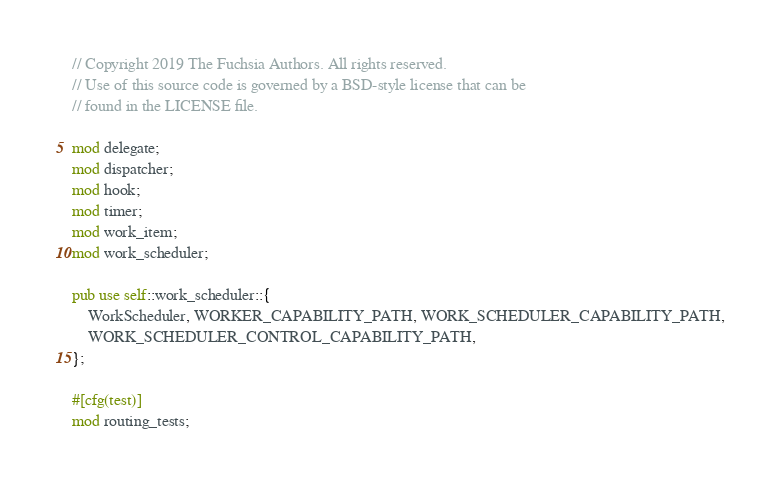Convert code to text. <code><loc_0><loc_0><loc_500><loc_500><_Rust_>// Copyright 2019 The Fuchsia Authors. All rights reserved.
// Use of this source code is governed by a BSD-style license that can be
// found in the LICENSE file.

mod delegate;
mod dispatcher;
mod hook;
mod timer;
mod work_item;
mod work_scheduler;

pub use self::work_scheduler::{
    WorkScheduler, WORKER_CAPABILITY_PATH, WORK_SCHEDULER_CAPABILITY_PATH,
    WORK_SCHEDULER_CONTROL_CAPABILITY_PATH,
};

#[cfg(test)]
mod routing_tests;
</code> 